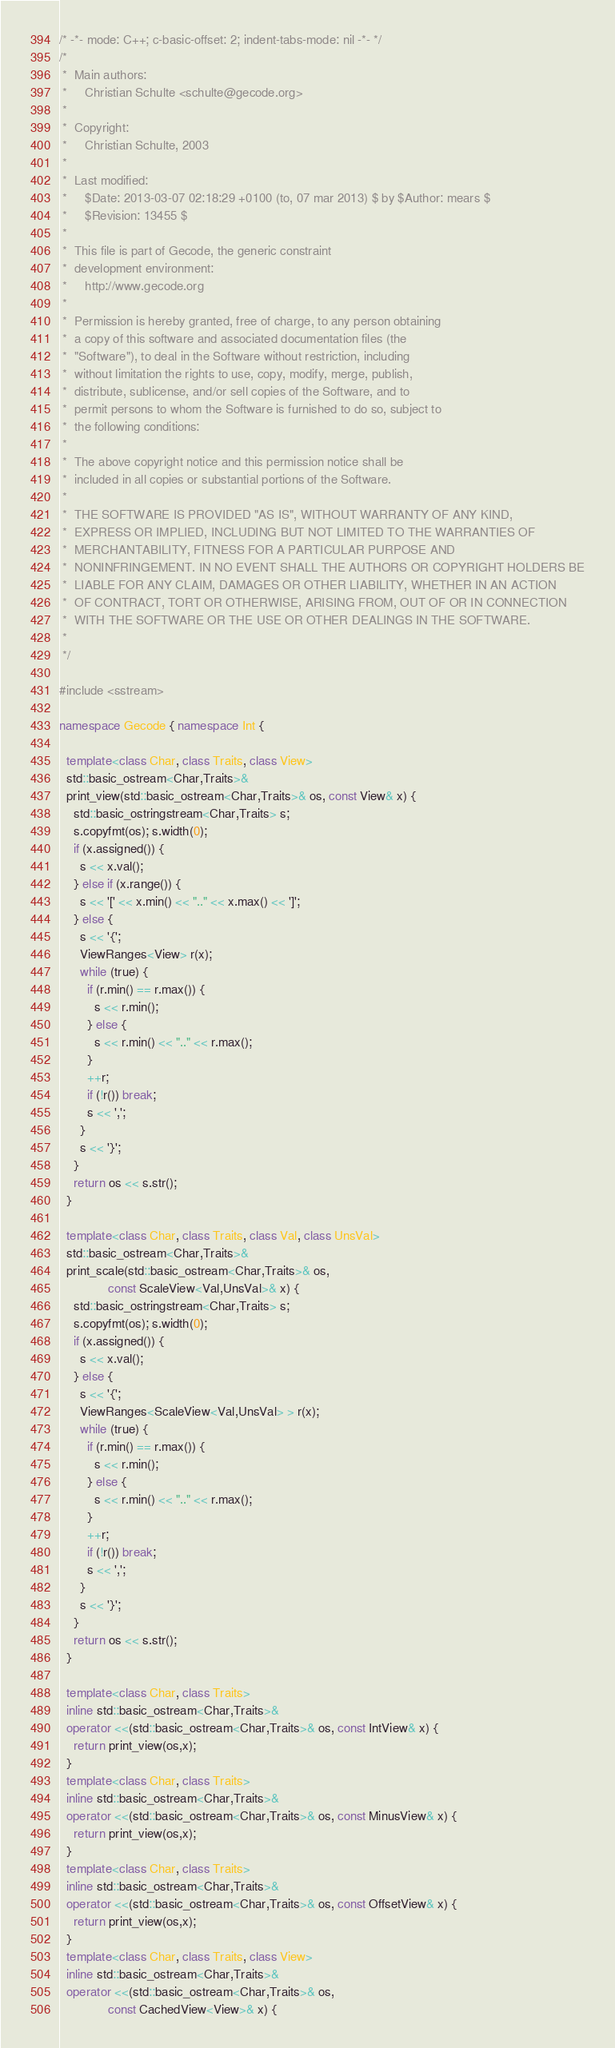Convert code to text. <code><loc_0><loc_0><loc_500><loc_500><_C++_>/* -*- mode: C++; c-basic-offset: 2; indent-tabs-mode: nil -*- */
/*
 *  Main authors:
 *     Christian Schulte <schulte@gecode.org>
 *
 *  Copyright:
 *     Christian Schulte, 2003
 *
 *  Last modified:
 *     $Date: 2013-03-07 02:18:29 +0100 (to, 07 mar 2013) $ by $Author: mears $
 *     $Revision: 13455 $
 *
 *  This file is part of Gecode, the generic constraint
 *  development environment:
 *     http://www.gecode.org
 *
 *  Permission is hereby granted, free of charge, to any person obtaining
 *  a copy of this software and associated documentation files (the
 *  "Software"), to deal in the Software without restriction, including
 *  without limitation the rights to use, copy, modify, merge, publish,
 *  distribute, sublicense, and/or sell copies of the Software, and to
 *  permit persons to whom the Software is furnished to do so, subject to
 *  the following conditions:
 *
 *  The above copyright notice and this permission notice shall be
 *  included in all copies or substantial portions of the Software.
 *
 *  THE SOFTWARE IS PROVIDED "AS IS", WITHOUT WARRANTY OF ANY KIND,
 *  EXPRESS OR IMPLIED, INCLUDING BUT NOT LIMITED TO THE WARRANTIES OF
 *  MERCHANTABILITY, FITNESS FOR A PARTICULAR PURPOSE AND
 *  NONINFRINGEMENT. IN NO EVENT SHALL THE AUTHORS OR COPYRIGHT HOLDERS BE
 *  LIABLE FOR ANY CLAIM, DAMAGES OR OTHER LIABILITY, WHETHER IN AN ACTION
 *  OF CONTRACT, TORT OR OTHERWISE, ARISING FROM, OUT OF OR IN CONNECTION
 *  WITH THE SOFTWARE OR THE USE OR OTHER DEALINGS IN THE SOFTWARE.
 *
 */

#include <sstream>

namespace Gecode { namespace Int {

  template<class Char, class Traits, class View>
  std::basic_ostream<Char,Traits>&
  print_view(std::basic_ostream<Char,Traits>& os, const View& x) {
    std::basic_ostringstream<Char,Traits> s;
    s.copyfmt(os); s.width(0);
    if (x.assigned()) {
      s << x.val();
    } else if (x.range()) {
      s << '[' << x.min() << ".." << x.max() << ']';
    } else {
      s << '{';
      ViewRanges<View> r(x);
      while (true) {
        if (r.min() == r.max()) {
          s << r.min();
        } else {
          s << r.min() << ".." << r.max();
        }
        ++r;
        if (!r()) break;
        s << ',';
      }
      s << '}';
    }
    return os << s.str();
  }

  template<class Char, class Traits, class Val, class UnsVal>
  std::basic_ostream<Char,Traits>&
  print_scale(std::basic_ostream<Char,Traits>& os,
              const ScaleView<Val,UnsVal>& x) {
    std::basic_ostringstream<Char,Traits> s;
    s.copyfmt(os); s.width(0);
    if (x.assigned()) {
      s << x.val();
    } else {
      s << '{';
      ViewRanges<ScaleView<Val,UnsVal> > r(x);
      while (true) {
        if (r.min() == r.max()) {
          s << r.min();
        } else {
          s << r.min() << ".." << r.max();
        }
        ++r;
        if (!r()) break;
        s << ',';
      }
      s << '}';
    }
    return os << s.str();
  }

  template<class Char, class Traits>
  inline std::basic_ostream<Char,Traits>&
  operator <<(std::basic_ostream<Char,Traits>& os, const IntView& x) {
    return print_view(os,x);
  }
  template<class Char, class Traits>
  inline std::basic_ostream<Char,Traits>&
  operator <<(std::basic_ostream<Char,Traits>& os, const MinusView& x) {
    return print_view(os,x);
  }
  template<class Char, class Traits>
  inline std::basic_ostream<Char,Traits>&
  operator <<(std::basic_ostream<Char,Traits>& os, const OffsetView& x) {
    return print_view(os,x);
  }
  template<class Char, class Traits, class View>
  inline std::basic_ostream<Char,Traits>&
  operator <<(std::basic_ostream<Char,Traits>& os,
              const CachedView<View>& x) {</code> 